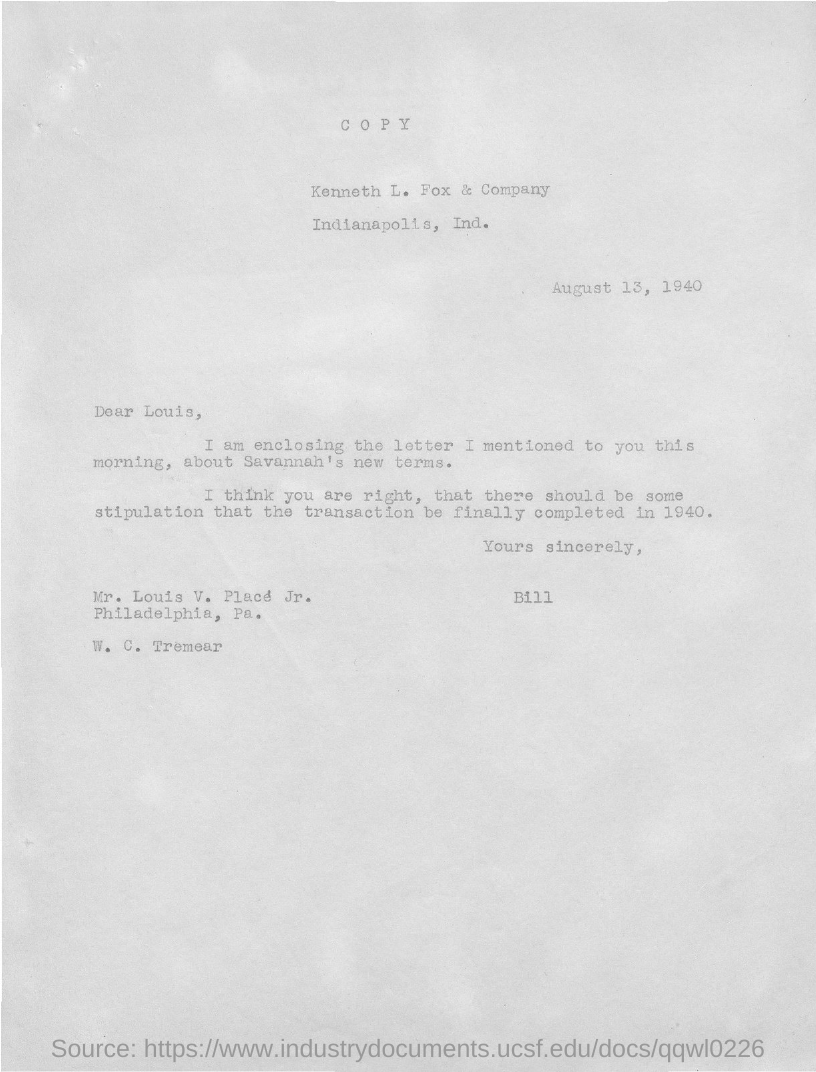Who wrote this letter?
Provide a succinct answer. Bill. To whom is this letter written to?
Your answer should be very brief. Louis. When is the letter dated ?
Ensure brevity in your answer.  August 13, 1940. 